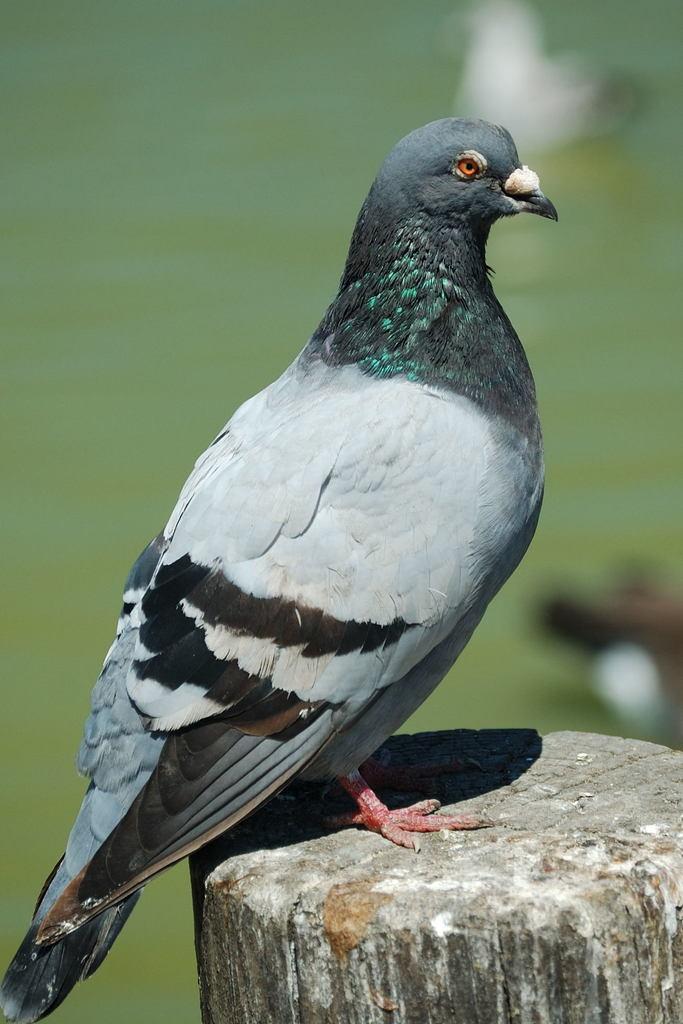Can you describe this image briefly? In the center of the image there is a bird standing on the wood. In the background there is a water. 